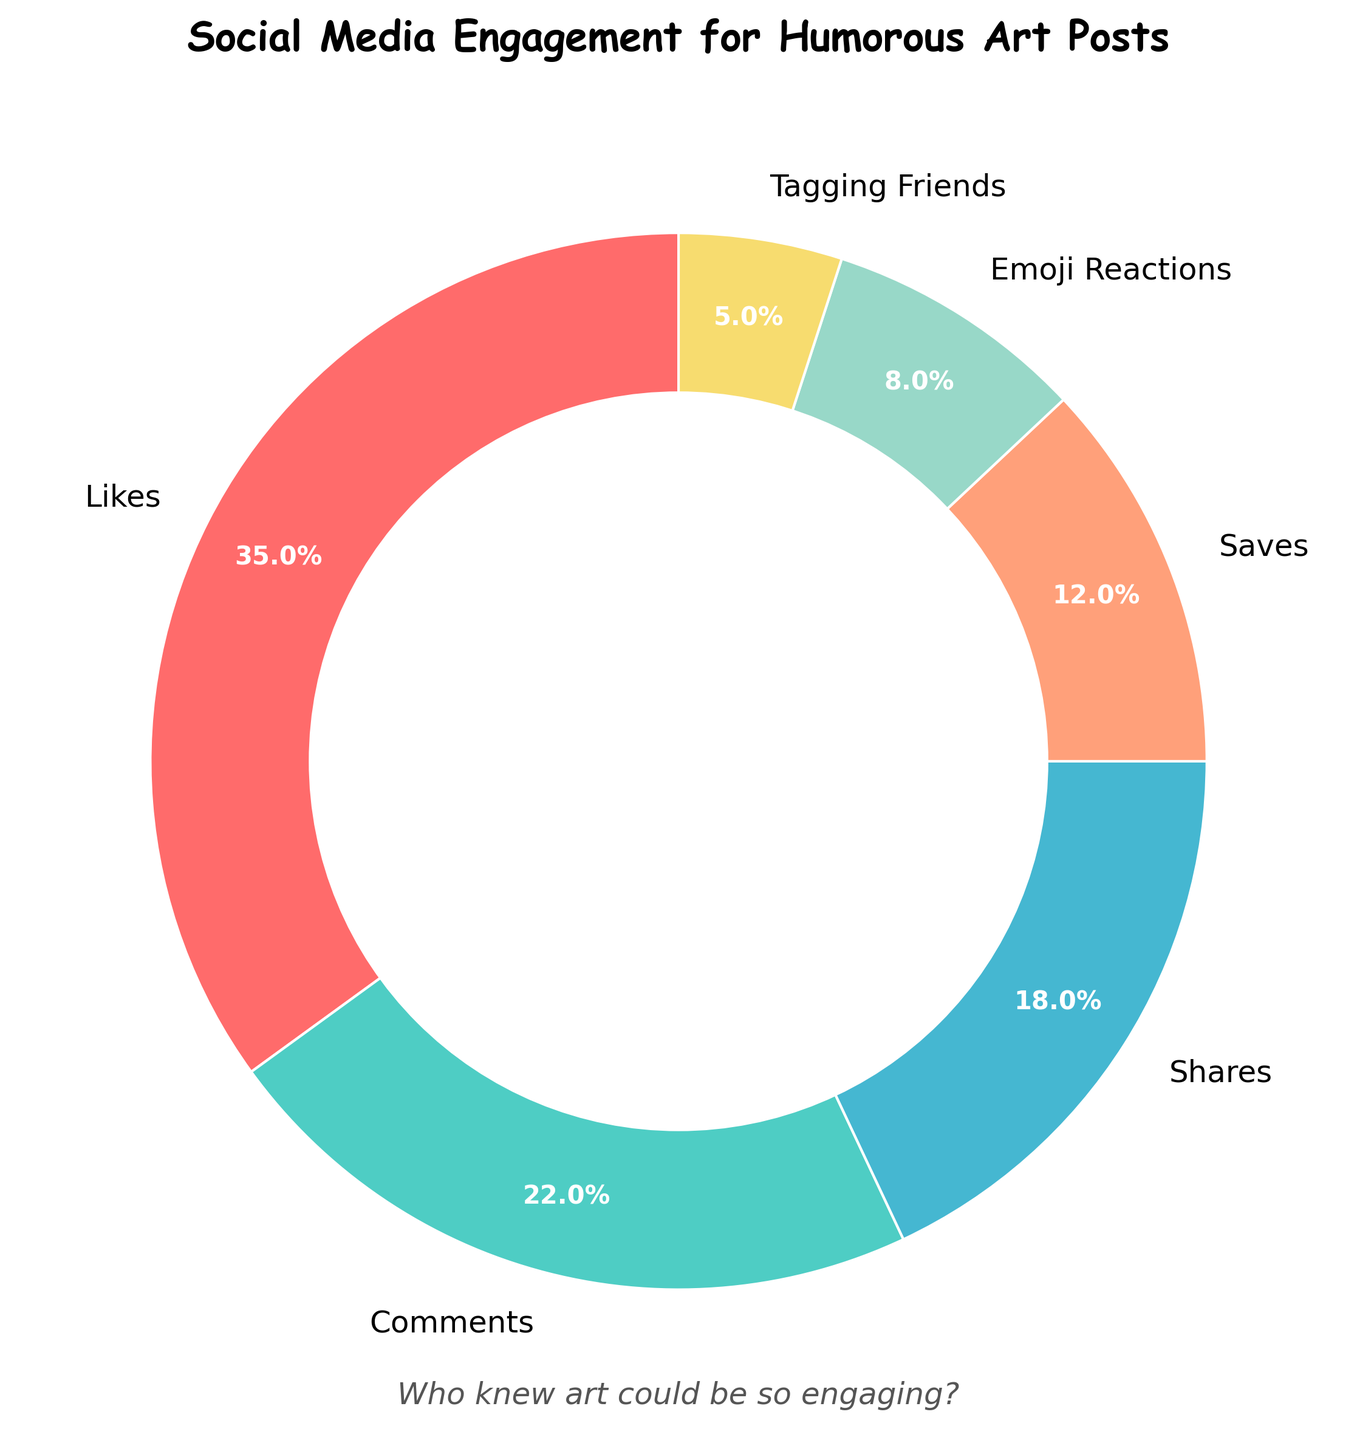What's the category with the highest percentage? Look at the pie chart and locate the segment with the largest size. Identify the label of this segment.
Answer: Likes Which category has a smaller percentage, Emoji Reactions or Tagging Friends? Compare the sizes of the two segments labeled "Emoji Reactions" and "Tagging Friends" to see which is smaller.
Answer: Tagging Friends What's the combined percentage of Shares and Saves? Identify the percentages for "Shares" and "Saves" from the chart, and add them together: 18% + 12%.
Answer: 30% Which category has close to a quarter of the total engagement? From the pie chart, see which category is labeled with a percentage close to 25%, finding "Comments" at 22%.
Answer: Comments What is the ratio of Likes to Emoji Reactions? Find the percentages for "Likes" (35%) and "Emoji Reactions" (8%). Divide 35 by 8 to get the ratio.
Answer: 4.375 How much more engagement do Shares have compared to Tagging Friends? Find the percentages for "Shares" (18%) and "Tagging Friends" (5%), then subtract the smaller percentage from the larger one: 18% - 5%.
Answer: 13% If you combine the engagement for Likes, Shares, and Comments, what percentage of total engagement do they represent? Add the percentages for "Likes" (35%), "Shares" (18%), and "Comments" (22%): 35% + 18% + 22%.
Answer: 75% Which segment has the smallest slice in the pie chart? Locate the smallest segment by visual inspection of the pie chart and read its label: "Tagging Friends".
Answer: Tagging Friends 